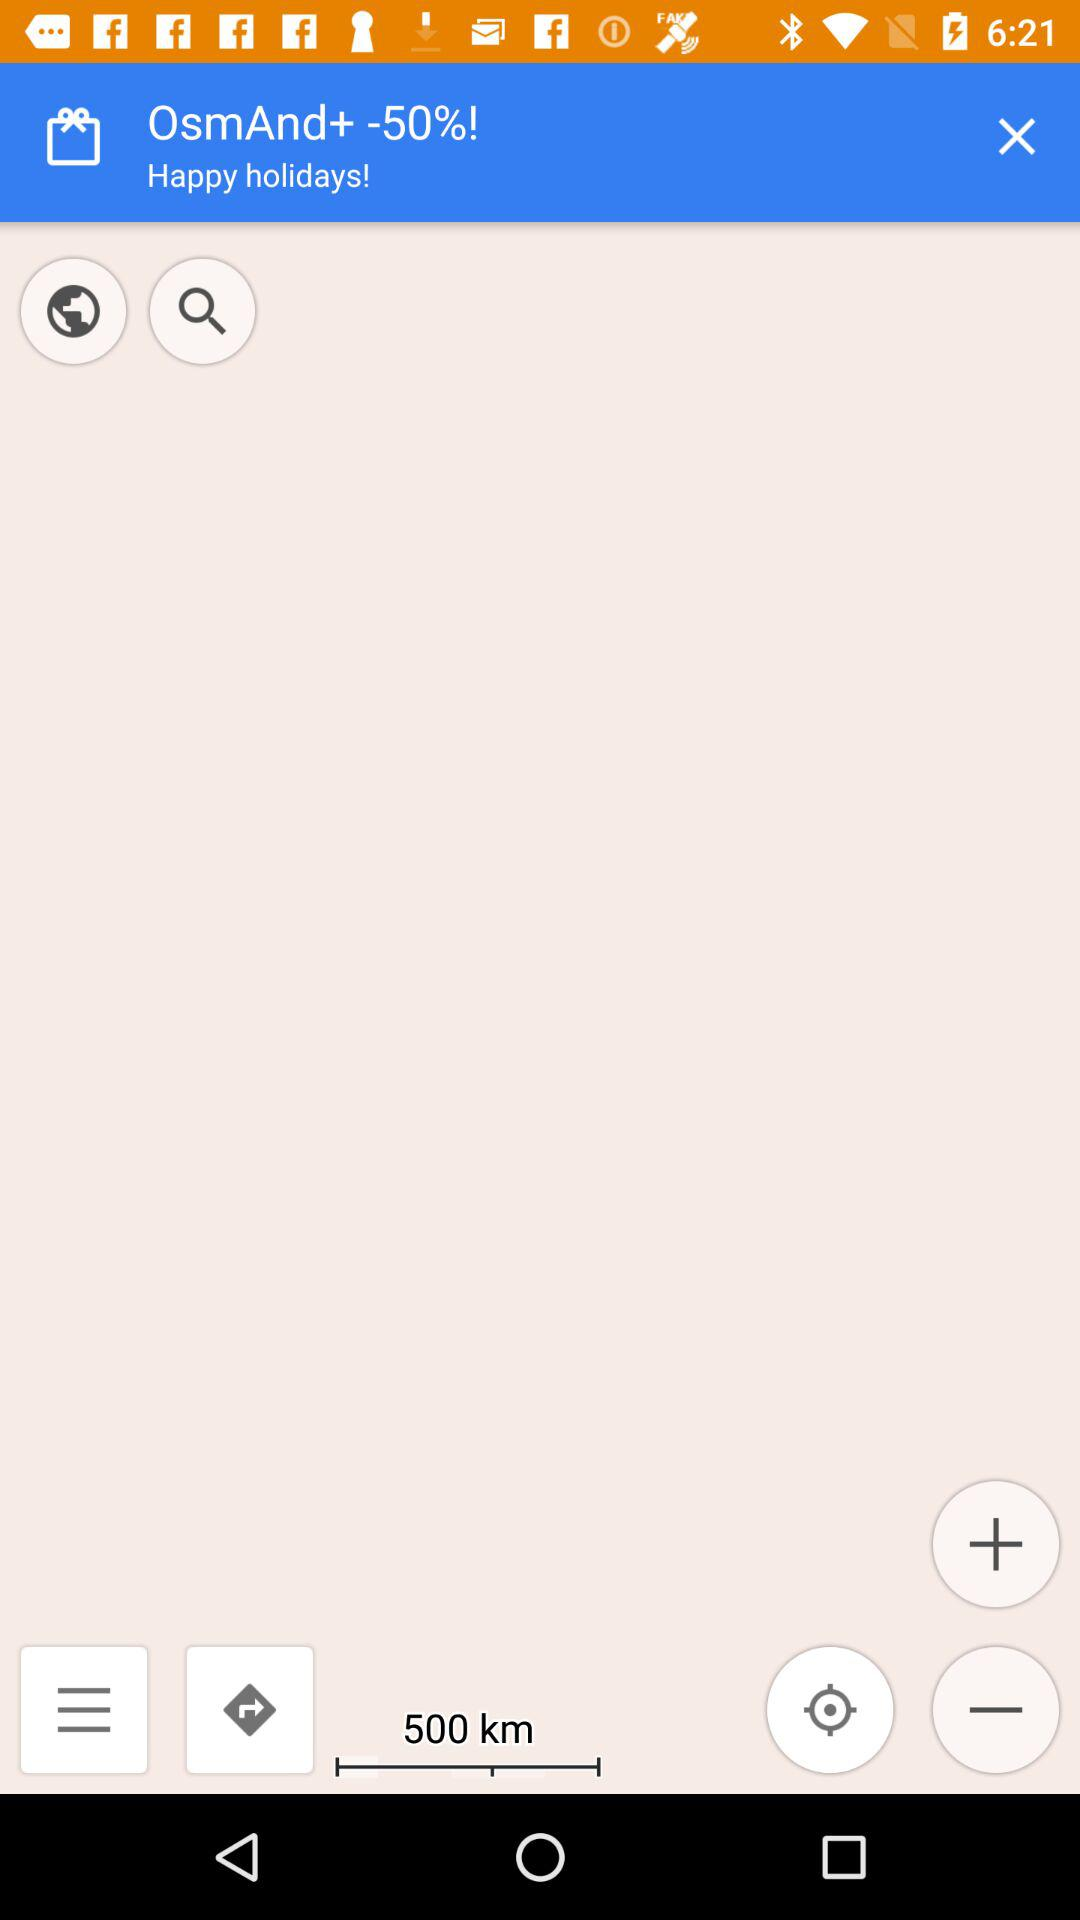How far is the destination?
Answer the question using a single word or phrase. 500 km 